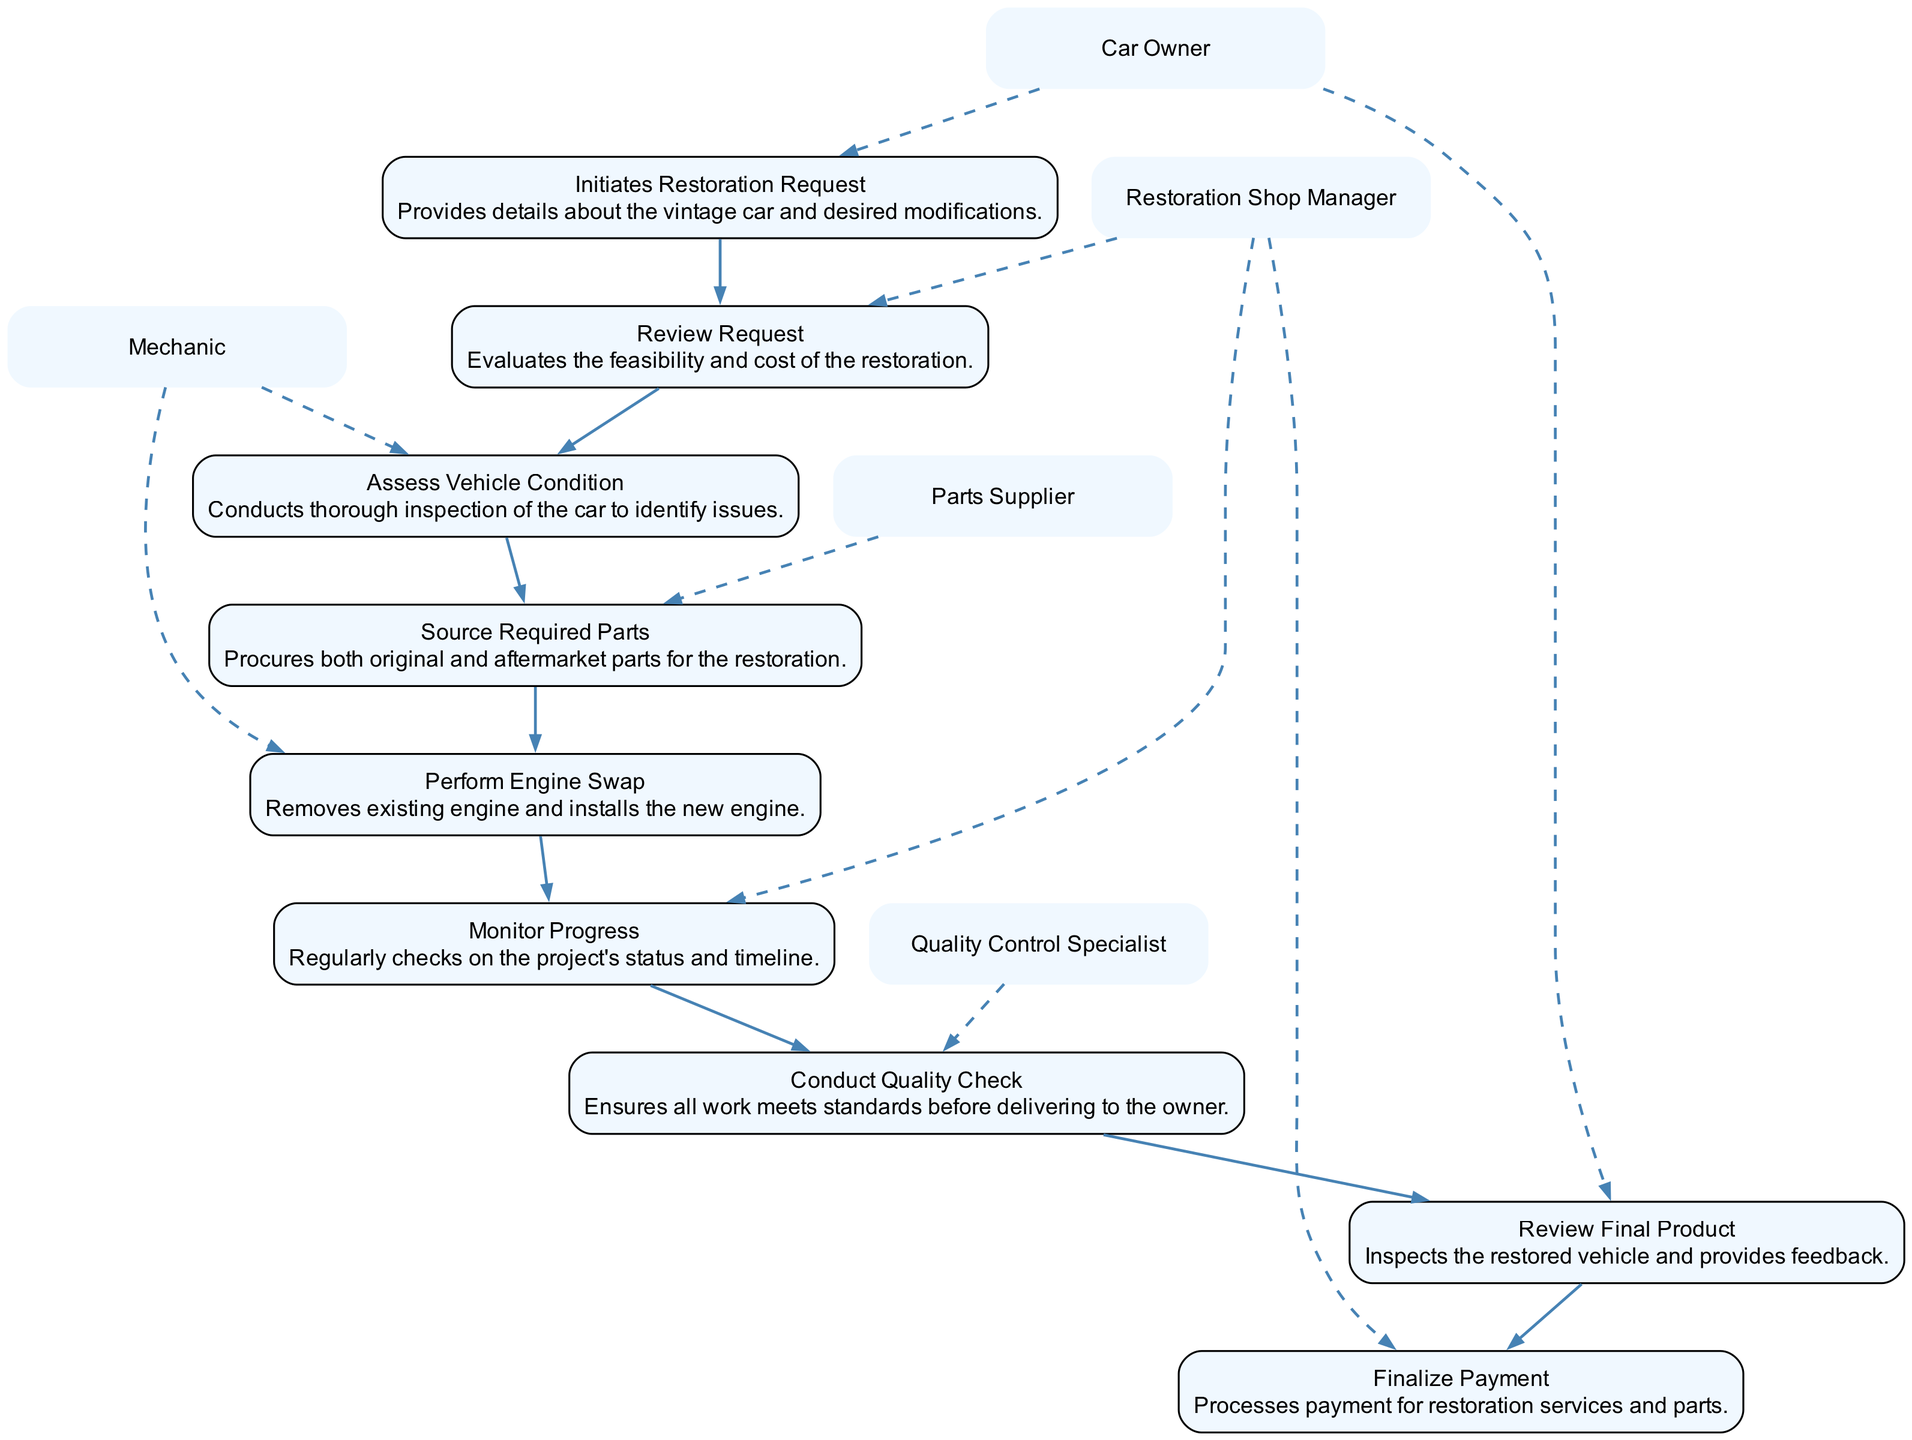What action does the Car Owner initiate? The initial action according to the diagram is "Initiates Restoration Request," where the Car Owner provides details about the vintage car and desired modifications.
Answer: Initiates Restoration Request How many actors are involved in the restoration process? The actors involved in the restoration process, as shown in the diagram, include the Car Owner, Restoration Shop Manager, Mechanic, Parts Supplier, and Quality Control Specialist. This totals to five distinct actors.
Answer: Five What is the first action taken by the Restoration Shop Manager? The first action taken by the Restoration Shop Manager is to "Review Request," as specified in the sequence after the Car Owner's initial submission.
Answer: Review Request Which actor sources the required parts for restoration? The actor responsible for sourcing the required parts is the "Parts Supplier," as stated in their specific action within the sequence.
Answer: Parts Supplier What step comes after the Mechanic performs the engine swap? After the Mechanic performs the engine swap, the next step involves the "Restoration Shop Manager" monitoring the progress of the restoration project.
Answer: Monitor Progress Which phase involves the Quality Control Specialist? The phase that involves the Quality Control Specialist occurs during the "Conduct Quality Check," where all work is ensured to meet standards.
Answer: Conduct Quality Check What does the Car Owner do after reviewing the final product? After reviewing the final product, the Car Owner provides feedback, concluding the inspection of the restored vehicle.
Answer: Provides feedback What action is connected directly after the quality check? The action that follows the quality check is "Finalize Payment," which is handled by the Restoration Shop Manager.
Answer: Finalize Payment Which action indicates the completion of the restoration process? The action indicating the completion of the restoration process is "Finalize Payment," as that signifies the end of the transaction once the Car Owner is satisfied.
Answer: Finalize Payment 